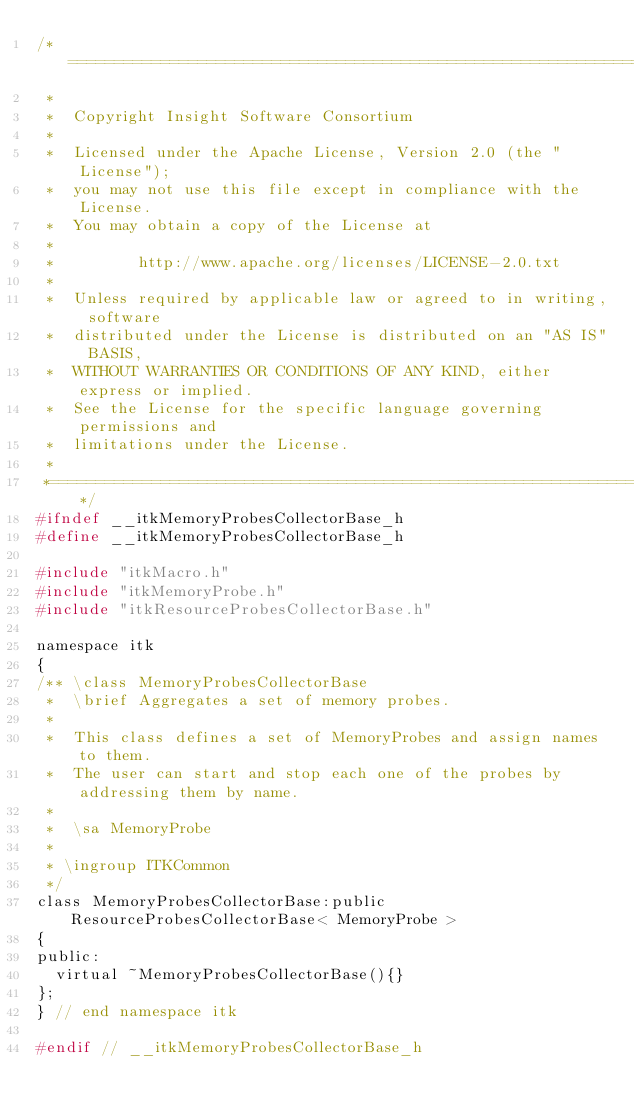Convert code to text. <code><loc_0><loc_0><loc_500><loc_500><_C_>/*=========================================================================
 *
 *  Copyright Insight Software Consortium
 *
 *  Licensed under the Apache License, Version 2.0 (the "License");
 *  you may not use this file except in compliance with the License.
 *  You may obtain a copy of the License at
 *
 *         http://www.apache.org/licenses/LICENSE-2.0.txt
 *
 *  Unless required by applicable law or agreed to in writing, software
 *  distributed under the License is distributed on an "AS IS" BASIS,
 *  WITHOUT WARRANTIES OR CONDITIONS OF ANY KIND, either express or implied.
 *  See the License for the specific language governing permissions and
 *  limitations under the License.
 *
 *=========================================================================*/
#ifndef __itkMemoryProbesCollectorBase_h
#define __itkMemoryProbesCollectorBase_h

#include "itkMacro.h"
#include "itkMemoryProbe.h"
#include "itkResourceProbesCollectorBase.h"

namespace itk
{
/** \class MemoryProbesCollectorBase
 *  \brief Aggregates a set of memory probes.
 *
 *  This class defines a set of MemoryProbes and assign names to them.
 *  The user can start and stop each one of the probes by addressing them by name.
 *
 *  \sa MemoryProbe
 *
 * \ingroup ITKCommon
 */
class MemoryProbesCollectorBase:public ResourceProbesCollectorBase< MemoryProbe >
{
public:
  virtual ~MemoryProbesCollectorBase(){}
};
} // end namespace itk

#endif // __itkMemoryProbesCollectorBase_h
</code> 